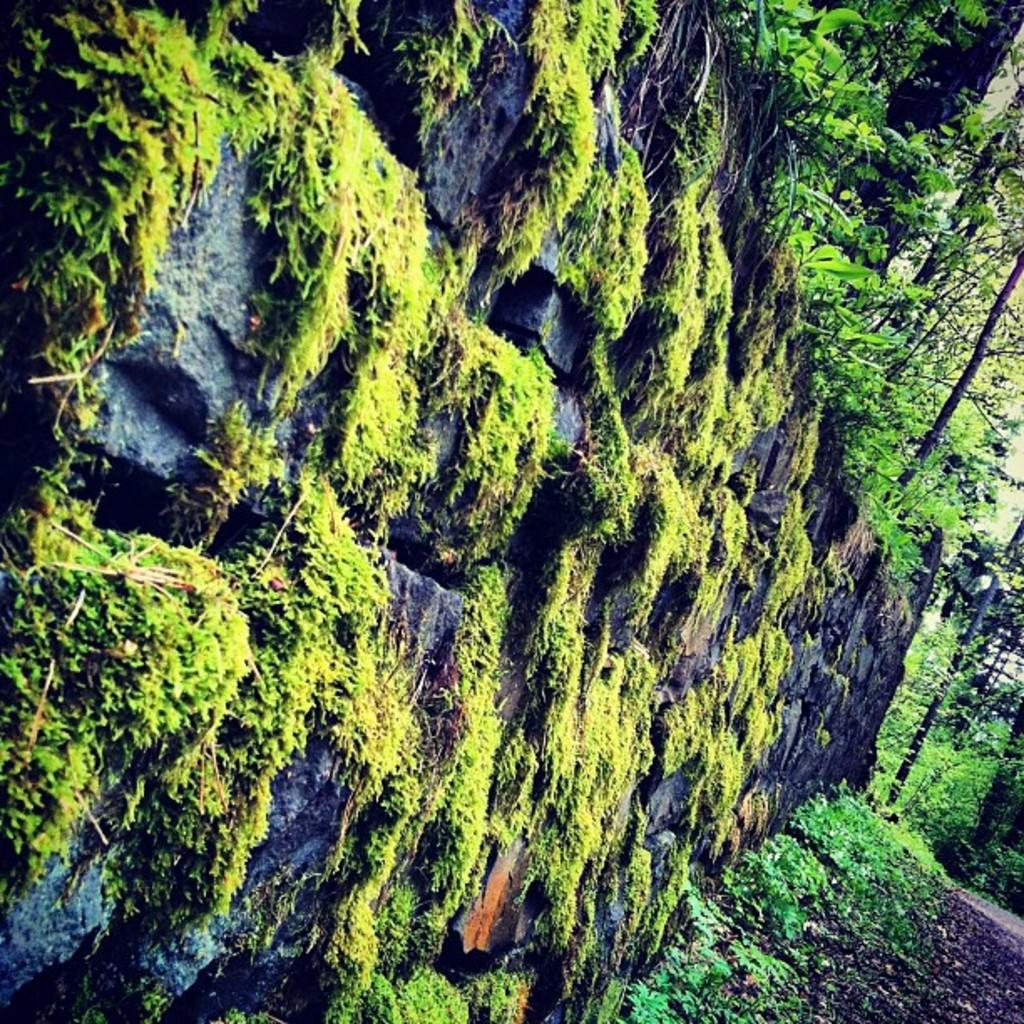What type of vegetation is on the wall in the image? There is grass on the wall in the image. What other types of vegetation can be seen in the image? There are trees and plants in the image. What type of fuel is being used to power the destruction in the image? There is no destruction or fuel present in the image; it features grass on the wall, trees, and plants. 